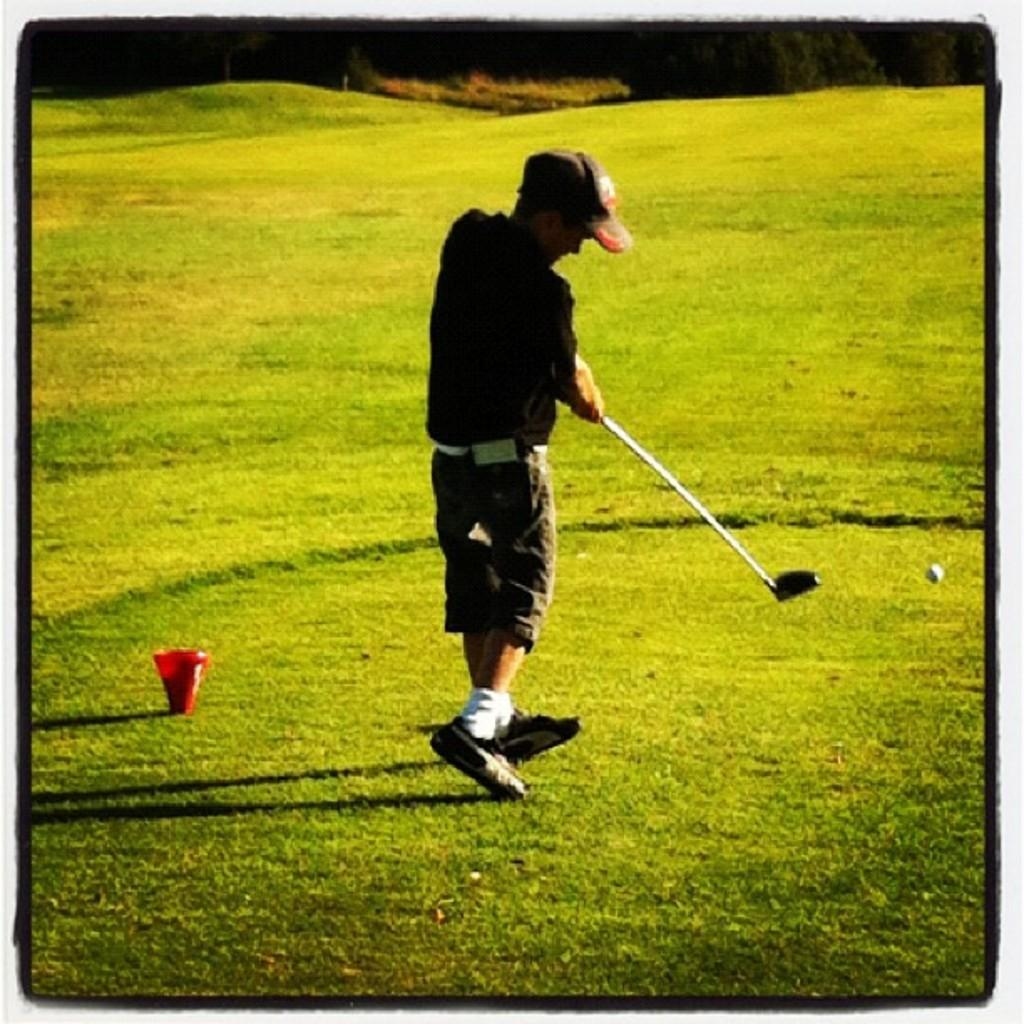Who is present in the image? There is a person in the image. What is the person wearing on their head? The person is wearing a cap. What is the person holding in their hand? The person is holding a golf stick. Where is the person located? The person is in a golf ground. What object related to golf can be seen on the right side of the image? There is a golf ball on the right side of the image. What type of snail can be seen crawling on the golf stick in the image? There is no snail present in the image; it only features a person, a cap, a golf stick, a golf ground, and a golf ball. 